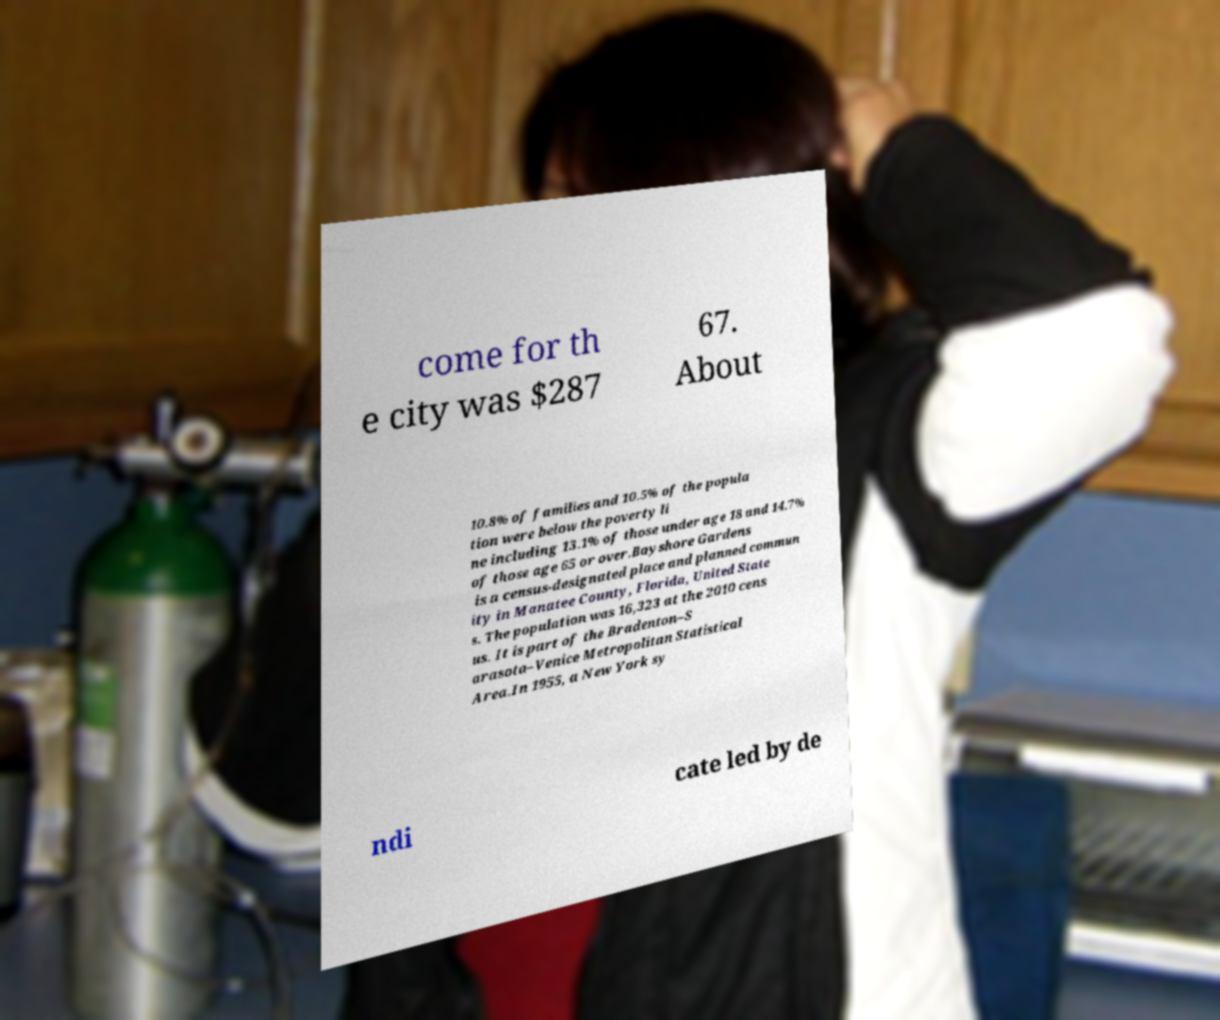Could you extract and type out the text from this image? come for th e city was $287 67. About 10.8% of families and 10.5% of the popula tion were below the poverty li ne including 13.1% of those under age 18 and 14.7% of those age 65 or over.Bayshore Gardens is a census-designated place and planned commun ity in Manatee County, Florida, United State s. The population was 16,323 at the 2010 cens us. It is part of the Bradenton–S arasota–Venice Metropolitan Statistical Area.In 1955, a New York sy ndi cate led by de 